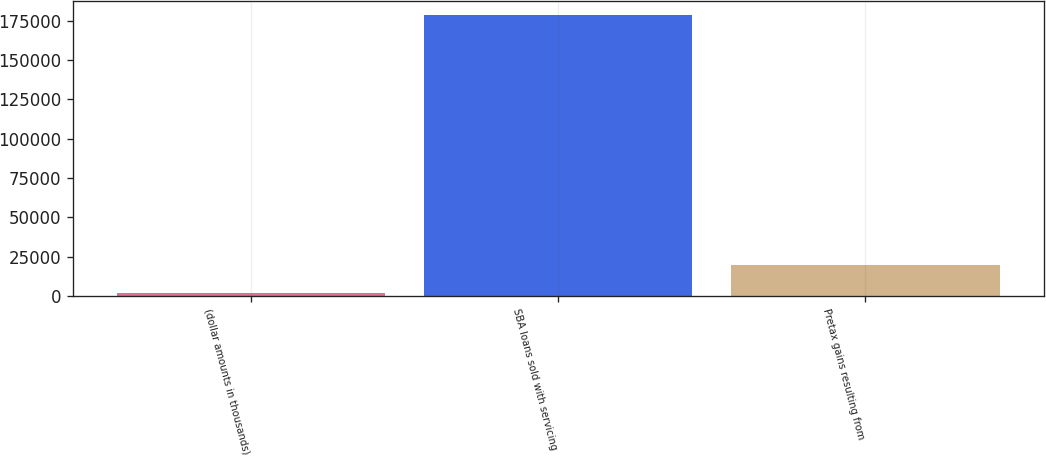Convert chart. <chart><loc_0><loc_0><loc_500><loc_500><bar_chart><fcel>(dollar amounts in thousands)<fcel>SBA loans sold with servicing<fcel>Pretax gains resulting from<nl><fcel>2013<fcel>178874<fcel>19699.1<nl></chart> 